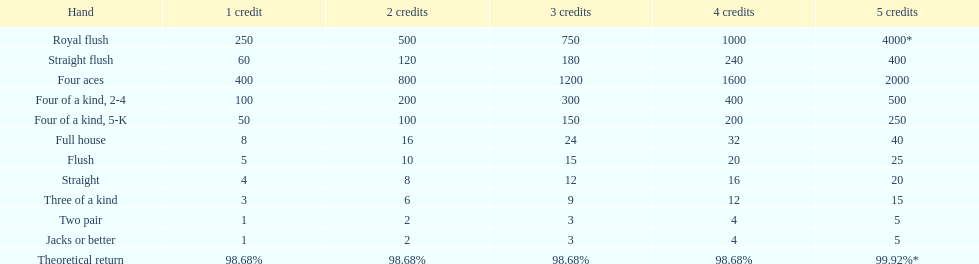I'm looking to parse the entire table for insights. Could you assist me with that? {'header': ['Hand', '1 credit', '2 credits', '3 credits', '4 credits', '5 credits'], 'rows': [['Royal flush', '250', '500', '750', '1000', '4000*'], ['Straight flush', '60', '120', '180', '240', '400'], ['Four aces', '400', '800', '1200', '1600', '2000'], ['Four of a kind, 2-4', '100', '200', '300', '400', '500'], ['Four of a kind, 5-K', '50', '100', '150', '200', '250'], ['Full house', '8', '16', '24', '32', '40'], ['Flush', '5', '10', '15', '20', '25'], ['Straight', '4', '8', '12', '16', '20'], ['Three of a kind', '3', '6', '9', '12', '15'], ['Two pair', '1', '2', '3', '4', '5'], ['Jacks or better', '1', '2', '3', '4', '5'], ['Theoretical return', '98.68%', '98.68%', '98.68%', '98.68%', '99.92%*']]} How many credits do you have to spend to get at least 2000 in payout if you had four aces? 5 credits. 